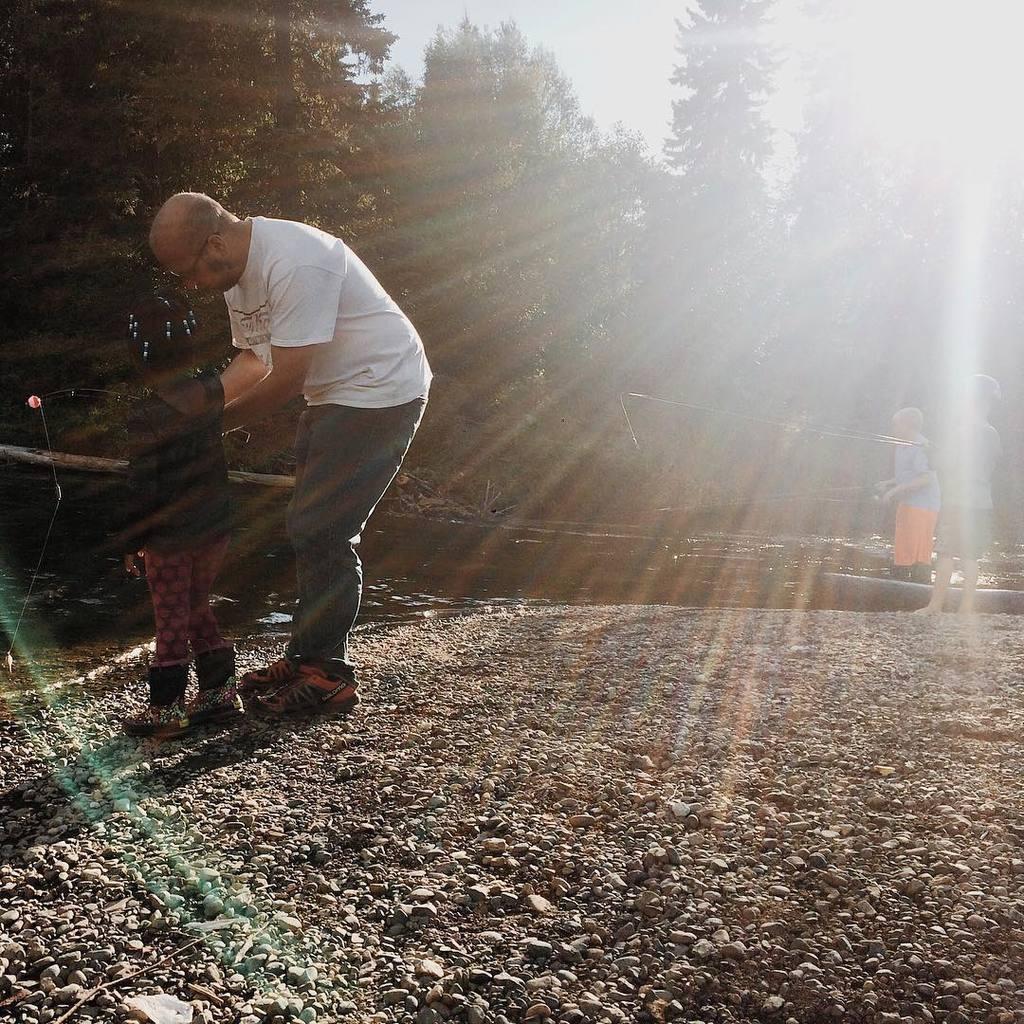Can you describe this image briefly? In the middle of the image few people are standing and holding some sticks. In front of them we can see water and trees. At the top of the image we can see sun in the sky. 